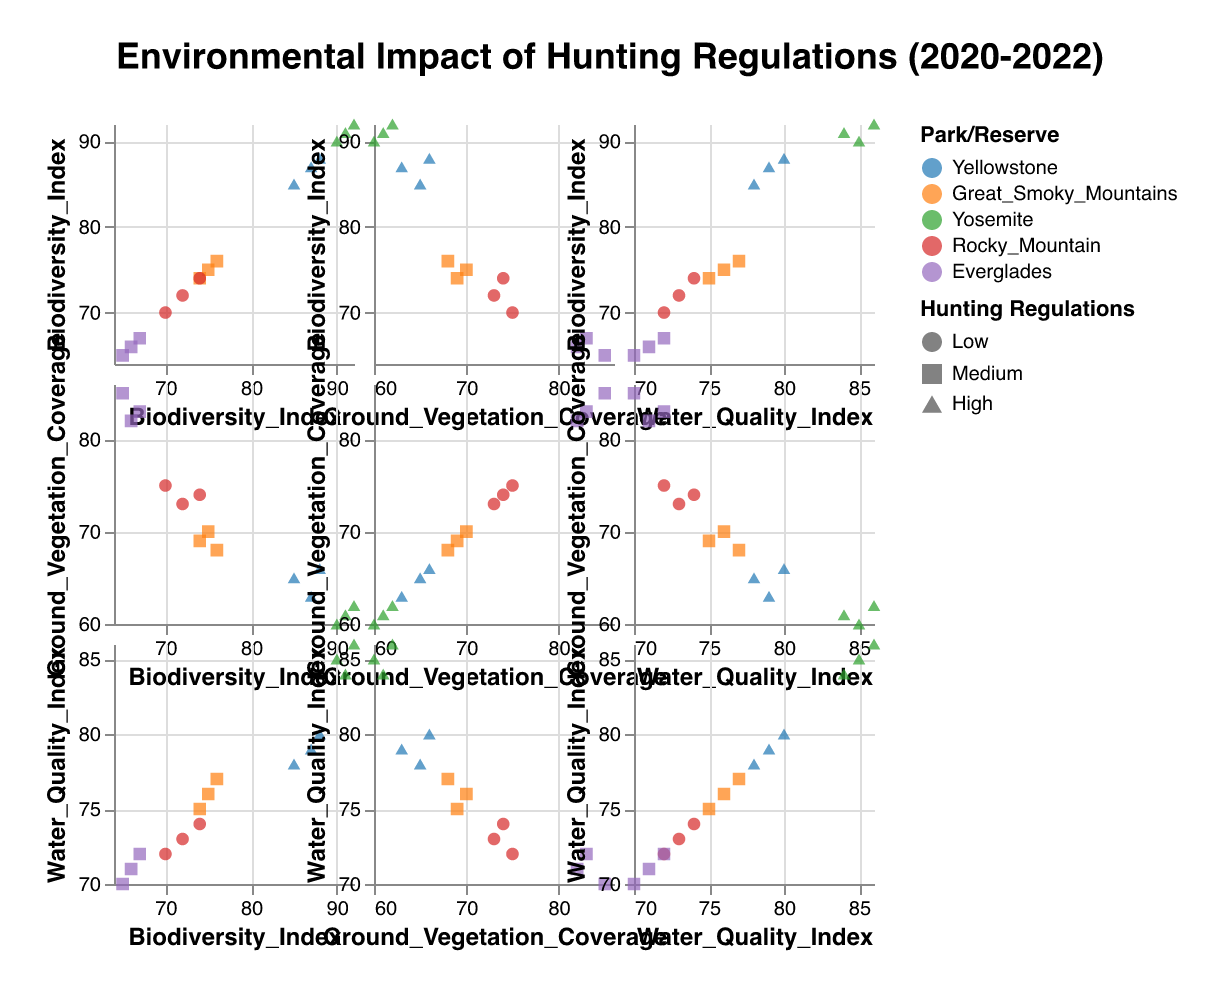What is the color used to represent data from Great Smoky Mountains? The legend on the right side shows that the color representing "Great Smoky Mountains" is orange
Answer: Orange How does the Biodiversity Index in Yosemite in 2022 compare to the Great Smoky Mountains in the same year? Yosemite in 2022 has a Biodiversity Index of 91, while the Great Smoky Mountains has a Biodiversity Index of 76. Comparing these values, 91 is greater than 76.
Answer: Biodiversity Index in Yosemite is higher Is there a relationship between Ground Vegetation Coverage and Water Quality Index in state parks with high hunting regulations strictness? By looking at the scatter plot for these variables with shapes indicating high hunting regulations strictness (triangles), we can analyze any visible trend. Generally, triangles are widely spread, suggesting no clear relationship.
Answer: No clear relationship Are there more data points for parks with medium hunting regulation strictness or low hunting regulation strictness? The legend shows medium strictness as squares and low strictness as circles. Counting the shapes, there are more squares than circles.
Answer: Medium strictness Which park shows the least variation in its Ground Vegetation Coverage from 2020 to 2022? Observing the scatter plots for Ground Vegetation Coverage across the years, the data points for Rocky Mountain appear closest with values ranging from 73 to 75, indicating the least variation.
Answer: Rocky Mountain Does the Water Quality Index in Everglades ever exceed 72 from 2020 to 2022? Reviewing the data points for Everglades in the Water Quality Index column, the highest recorded value is 72.
Answer: No What is the average Biodiversity Index for Yellowstone over the three years? Summing the Biodiversity Index values for Yellowstone (85, 88, 87) and dividing by 3 gives (85 + 88 + 87) / 3 = 260 / 3 = 86.67
Answer: 86.67 Which park has the highest Ground Vegetation Coverage in 2020? By checking the Ground Vegetation Coverage values for 2020, Everglades has the highest value of 85.
Answer: Everglades 